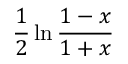Convert formula to latex. <formula><loc_0><loc_0><loc_500><loc_500>\frac { 1 } { 2 } \ln \frac { 1 - x } { 1 + x }</formula> 